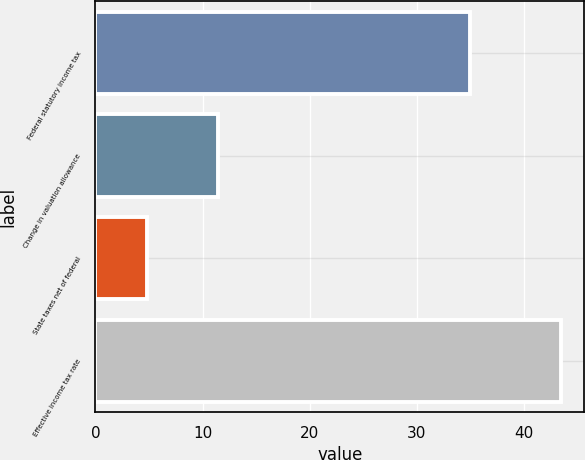<chart> <loc_0><loc_0><loc_500><loc_500><bar_chart><fcel>Federal statutory income tax<fcel>Change in valuation allowance<fcel>State taxes net of federal<fcel>Effective income tax rate<nl><fcel>35<fcel>11.4<fcel>4.8<fcel>43.5<nl></chart> 